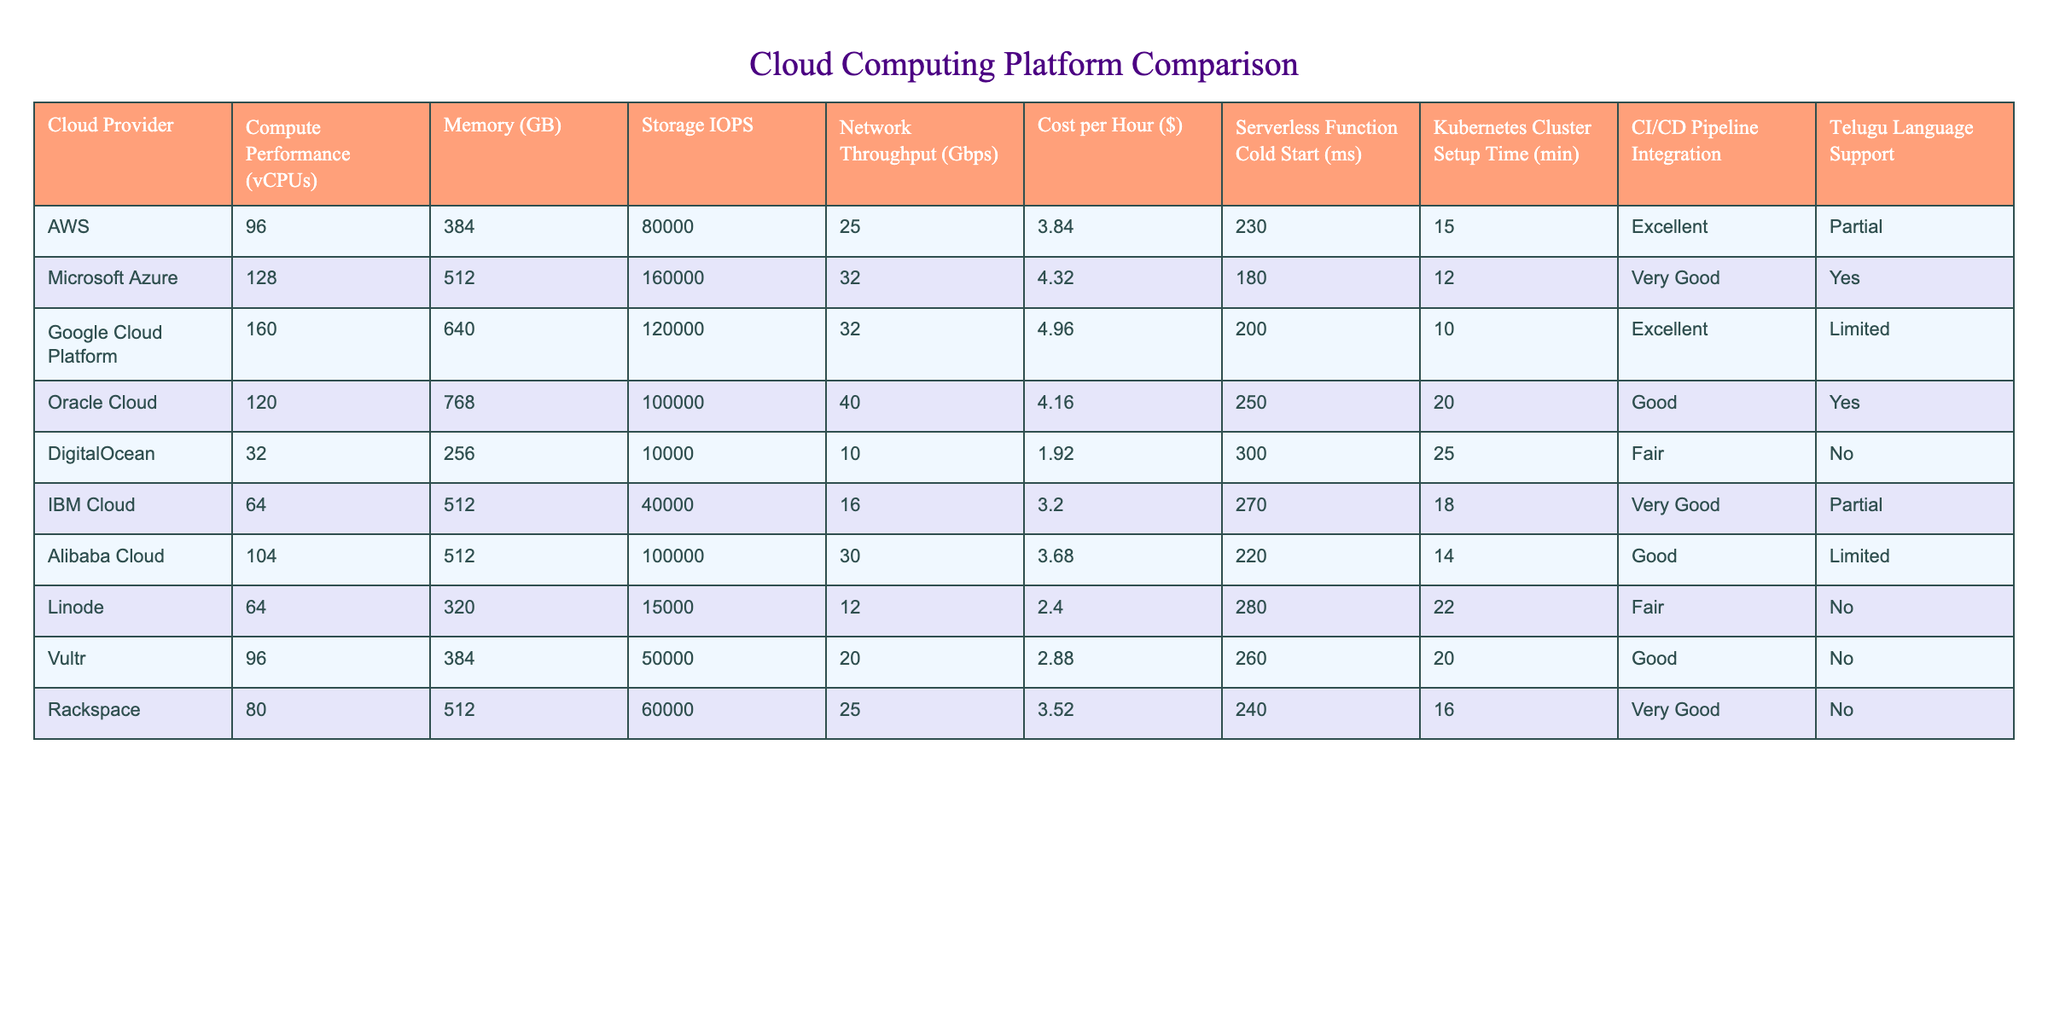What is the maximum Compute Performance (vCPUs) offered by a cloud provider? From the table, I can see that Google Cloud Platform offers 160 vCPUs, which is the highest compared to other providers listed.
Answer: 160 Which cloud provider has the lowest cost per hour? By looking at the "Cost per Hour" column, DigitalOcean has the lowest cost at $1.92 per hour, which is less than any other provider.
Answer: $1.92 What is the average memory provided by cloud providers? To find the average memory, I sum all the memory values: 384 + 512 + 640 + 768 + 256 + 512 + 512 + 320 + 384 + 512 =  5128. There are 10 providers, so the average is 5128/10 = 512.8 GB.
Answer: 512.8 GB Which cloud provider has the highest network throughput and what is its value? The highest value in the "Network Throughput" column is 40 Gbps, which corresponds to Oracle Cloud. Therefore, Oracle Cloud provides the highest network throughput.
Answer: Oracle Cloud, 40 Gbps Is there any cloud provider that offers Telugu language support? If we check the "Telugu Language Support" column, Microsoft Azure and Oracle Cloud both offer "Yes" for Telugu Language Support, which confirms that there are providers offering it.
Answer: Yes What is the difference in Storage IOPS between the highest and the lowest cloud provider? From the data, Google Cloud Platform has the highest Storage IOPS at 120000. The lowest is DigitalOcean with 10000. The difference is 120000 - 10000 = 110000.
Answer: 110000 Which cloud provider requires the least amount of time to set up a Kubernetes cluster? By examining the "Kubernetes Cluster Setup Time" column, Google Cloud Platform requires only 10 minutes, which is the shortest setup time among all cloud providers listed in the table.
Answer: Google Cloud Platform, 10 minutes How many providers offer Very Good CI/CD Pipeline Integration? The “CI/CD Pipeline Integration” column lists "Very Good" for Microsoft Azure, IBM Cloud, and Rackspace, indicating that there are a total of three providers offering this level of support.
Answer: 3 What is the total number of vCPUs across cloud providers that support Telugu Language? The cloud providers supporting Telugu Language are Microsoft Azure (128 vCPUs), Oracle Cloud (120 vCPUs), and IBM Cloud (64 vCPUs). Summing them gives 128 + 120 + 64 = 312 vCPUs total.
Answer: 312 vCPUs 